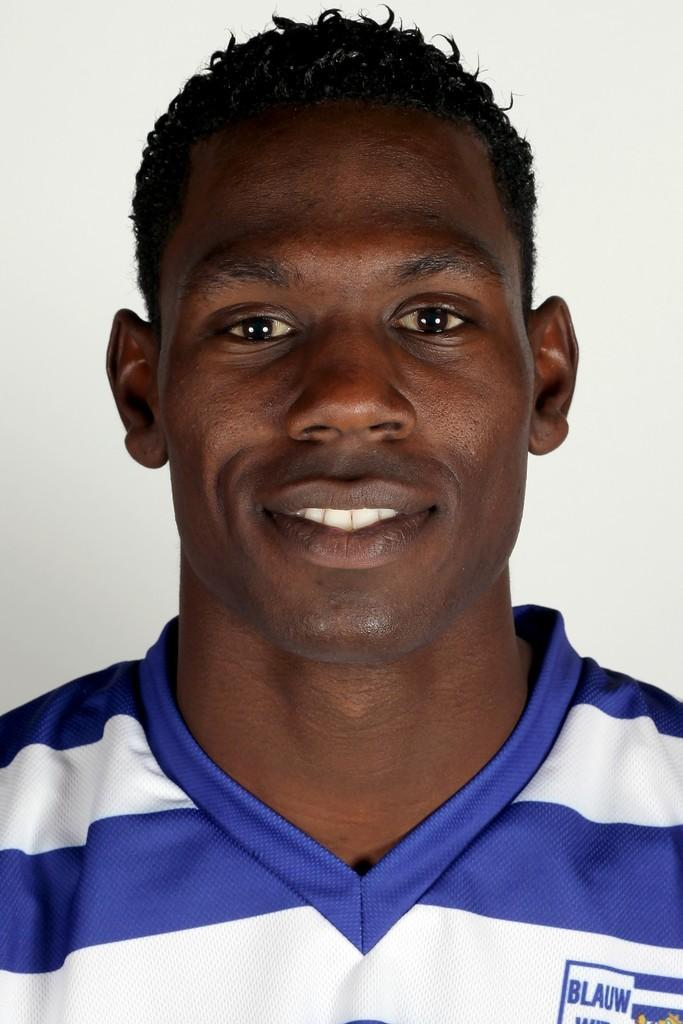<image>
Offer a succinct explanation of the picture presented. Headshot of man in striped blue and white shirt that reads "Blauw" 